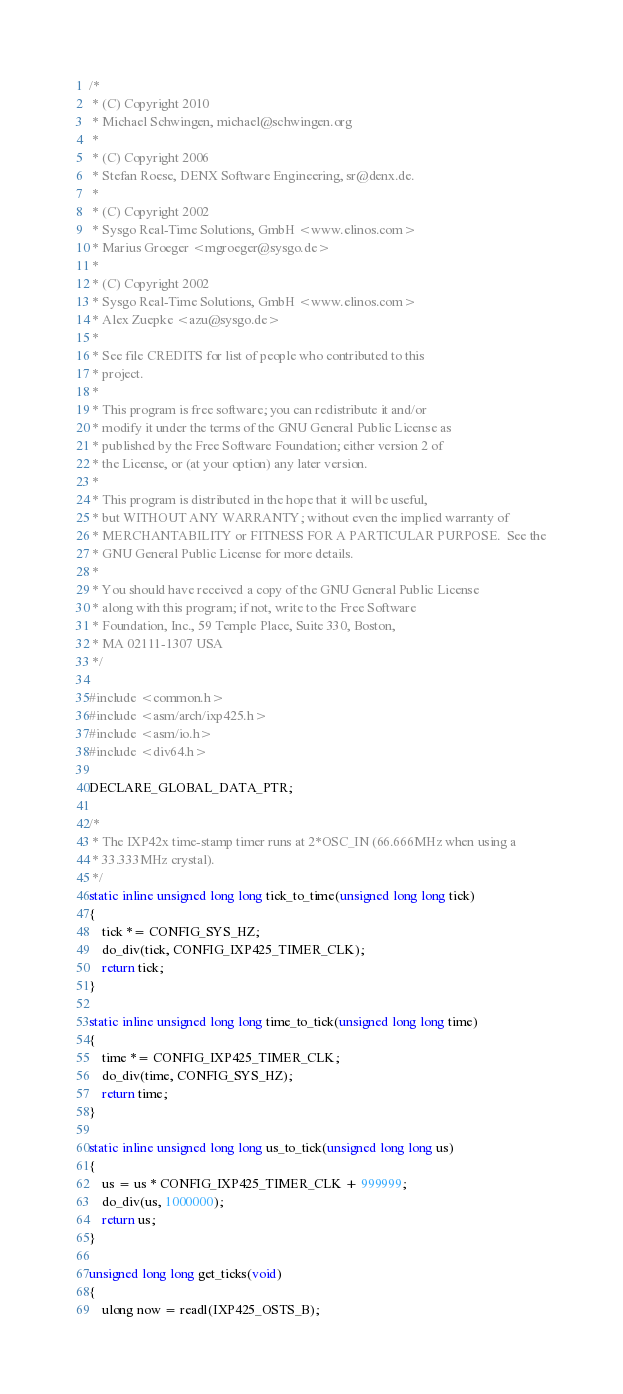Convert code to text. <code><loc_0><loc_0><loc_500><loc_500><_C_>/*
 * (C) Copyright 2010
 * Michael Schwingen, michael@schwingen.org
 *
 * (C) Copyright 2006
 * Stefan Roese, DENX Software Engineering, sr@denx.de.
 *
 * (C) Copyright 2002
 * Sysgo Real-Time Solutions, GmbH <www.elinos.com>
 * Marius Groeger <mgroeger@sysgo.de>
 *
 * (C) Copyright 2002
 * Sysgo Real-Time Solutions, GmbH <www.elinos.com>
 * Alex Zuepke <azu@sysgo.de>
 *
 * See file CREDITS for list of people who contributed to this
 * project.
 *
 * This program is free software; you can redistribute it and/or
 * modify it under the terms of the GNU General Public License as
 * published by the Free Software Foundation; either version 2 of
 * the License, or (at your option) any later version.
 *
 * This program is distributed in the hope that it will be useful,
 * but WITHOUT ANY WARRANTY; without even the implied warranty of
 * MERCHANTABILITY or FITNESS FOR A PARTICULAR PURPOSE.  See the
 * GNU General Public License for more details.
 *
 * You should have received a copy of the GNU General Public License
 * along with this program; if not, write to the Free Software
 * Foundation, Inc., 59 Temple Place, Suite 330, Boston,
 * MA 02111-1307 USA
 */

#include <common.h>
#include <asm/arch/ixp425.h>
#include <asm/io.h>
#include <div64.h>

DECLARE_GLOBAL_DATA_PTR;

/*
 * The IXP42x time-stamp timer runs at 2*OSC_IN (66.666MHz when using a
 * 33.333MHz crystal).
 */
static inline unsigned long long tick_to_time(unsigned long long tick)
{
	tick *= CONFIG_SYS_HZ;
	do_div(tick, CONFIG_IXP425_TIMER_CLK);
	return tick;
}

static inline unsigned long long time_to_tick(unsigned long long time)
{
	time *= CONFIG_IXP425_TIMER_CLK;
	do_div(time, CONFIG_SYS_HZ);
	return time;
}

static inline unsigned long long us_to_tick(unsigned long long us)
{
	us = us * CONFIG_IXP425_TIMER_CLK + 999999;
	do_div(us, 1000000);
	return us;
}

unsigned long long get_ticks(void)
{
	ulong now = readl(IXP425_OSTS_B);
</code> 